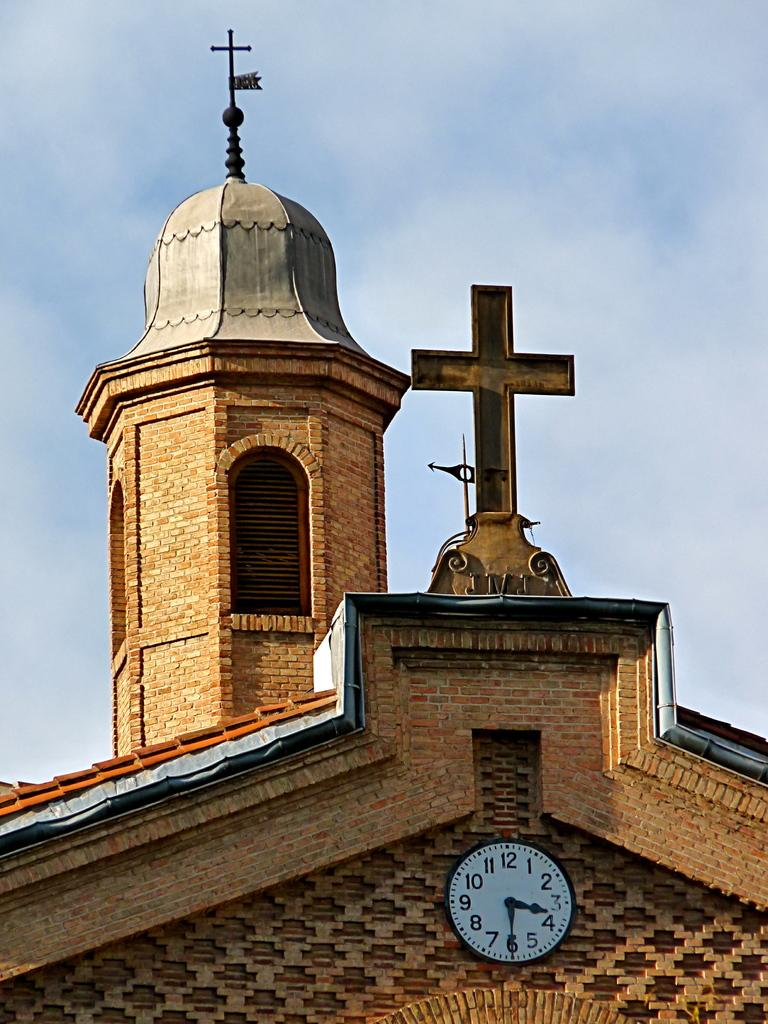Provide a one-sentence caption for the provided image. Church with a clock that has the hands on the 3 and 6. 